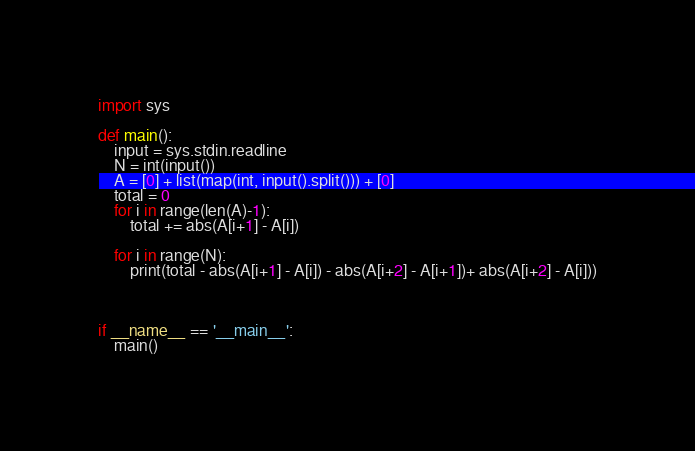Convert code to text. <code><loc_0><loc_0><loc_500><loc_500><_Python_>import sys

def main():
    input = sys.stdin.readline
    N = int(input())
    A = [0] + list(map(int, input().split())) + [0]
    total = 0
    for i in range(len(A)-1):
        total += abs(A[i+1] - A[i])

    for i in range(N):
        print(total - abs(A[i+1] - A[i]) - abs(A[i+2] - A[i+1])+ abs(A[i+2] - A[i]))



if __name__ == '__main__':
    main()
</code> 